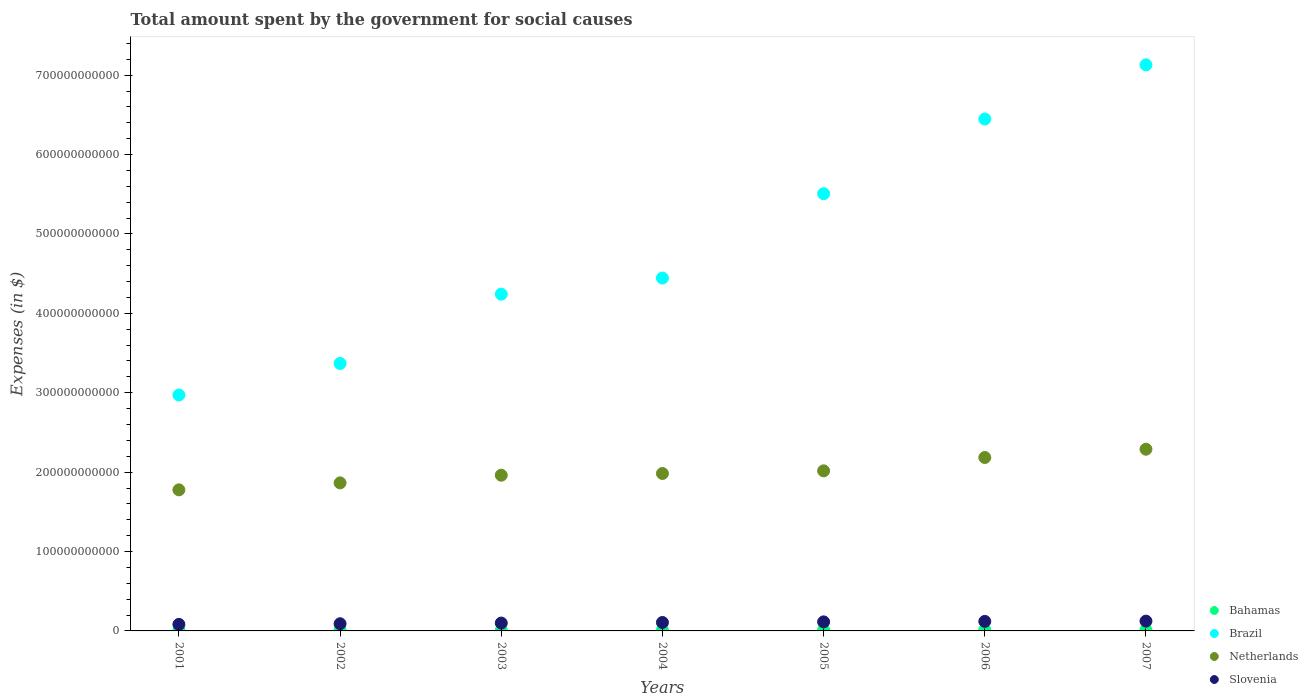How many different coloured dotlines are there?
Your answer should be compact. 4. What is the amount spent for social causes by the government in Netherlands in 2003?
Provide a succinct answer. 1.96e+11. Across all years, what is the maximum amount spent for social causes by the government in Bahamas?
Your answer should be compact. 1.26e+09. Across all years, what is the minimum amount spent for social causes by the government in Netherlands?
Provide a succinct answer. 1.78e+11. In which year was the amount spent for social causes by the government in Brazil maximum?
Ensure brevity in your answer.  2007. In which year was the amount spent for social causes by the government in Brazil minimum?
Your answer should be compact. 2001. What is the total amount spent for social causes by the government in Brazil in the graph?
Provide a short and direct response. 3.41e+12. What is the difference between the amount spent for social causes by the government in Bahamas in 2002 and that in 2003?
Keep it short and to the point. -7.63e+07. What is the difference between the amount spent for social causes by the government in Bahamas in 2004 and the amount spent for social causes by the government in Brazil in 2007?
Ensure brevity in your answer.  -7.12e+11. What is the average amount spent for social causes by the government in Netherlands per year?
Offer a terse response. 2.01e+11. In the year 2007, what is the difference between the amount spent for social causes by the government in Netherlands and amount spent for social causes by the government in Slovenia?
Make the answer very short. 2.17e+11. What is the ratio of the amount spent for social causes by the government in Brazil in 2002 to that in 2005?
Your answer should be very brief. 0.61. Is the amount spent for social causes by the government in Brazil in 2003 less than that in 2007?
Give a very brief answer. Yes. What is the difference between the highest and the second highest amount spent for social causes by the government in Netherlands?
Your response must be concise. 1.04e+1. What is the difference between the highest and the lowest amount spent for social causes by the government in Netherlands?
Ensure brevity in your answer.  5.12e+1. In how many years, is the amount spent for social causes by the government in Bahamas greater than the average amount spent for social causes by the government in Bahamas taken over all years?
Give a very brief answer. 3. Is the sum of the amount spent for social causes by the government in Slovenia in 2003 and 2005 greater than the maximum amount spent for social causes by the government in Brazil across all years?
Give a very brief answer. No. Is it the case that in every year, the sum of the amount spent for social causes by the government in Bahamas and amount spent for social causes by the government in Netherlands  is greater than the sum of amount spent for social causes by the government in Slovenia and amount spent for social causes by the government in Brazil?
Provide a succinct answer. Yes. Is the amount spent for social causes by the government in Slovenia strictly greater than the amount spent for social causes by the government in Bahamas over the years?
Make the answer very short. Yes. What is the difference between two consecutive major ticks on the Y-axis?
Your response must be concise. 1.00e+11. Are the values on the major ticks of Y-axis written in scientific E-notation?
Provide a short and direct response. No. How are the legend labels stacked?
Make the answer very short. Vertical. What is the title of the graph?
Make the answer very short. Total amount spent by the government for social causes. What is the label or title of the Y-axis?
Your answer should be compact. Expenses (in $). What is the Expenses (in $) in Bahamas in 2001?
Offer a terse response. 8.67e+08. What is the Expenses (in $) in Brazil in 2001?
Keep it short and to the point. 2.97e+11. What is the Expenses (in $) in Netherlands in 2001?
Offer a terse response. 1.78e+11. What is the Expenses (in $) of Slovenia in 2001?
Ensure brevity in your answer.  8.24e+09. What is the Expenses (in $) of Bahamas in 2002?
Provide a short and direct response. 9.23e+08. What is the Expenses (in $) of Brazil in 2002?
Provide a succinct answer. 3.37e+11. What is the Expenses (in $) in Netherlands in 2002?
Offer a terse response. 1.86e+11. What is the Expenses (in $) in Slovenia in 2002?
Provide a succinct answer. 9.05e+09. What is the Expenses (in $) in Bahamas in 2003?
Make the answer very short. 9.99e+08. What is the Expenses (in $) in Brazil in 2003?
Offer a terse response. 4.24e+11. What is the Expenses (in $) in Netherlands in 2003?
Your answer should be very brief. 1.96e+11. What is the Expenses (in $) of Slovenia in 2003?
Offer a very short reply. 9.91e+09. What is the Expenses (in $) in Bahamas in 2004?
Provide a short and direct response. 1.02e+09. What is the Expenses (in $) of Brazil in 2004?
Provide a succinct answer. 4.44e+11. What is the Expenses (in $) in Netherlands in 2004?
Make the answer very short. 1.98e+11. What is the Expenses (in $) of Slovenia in 2004?
Keep it short and to the point. 1.06e+1. What is the Expenses (in $) of Bahamas in 2005?
Your answer should be very brief. 1.12e+09. What is the Expenses (in $) of Brazil in 2005?
Your answer should be compact. 5.51e+11. What is the Expenses (in $) of Netherlands in 2005?
Offer a terse response. 2.02e+11. What is the Expenses (in $) in Slovenia in 2005?
Your response must be concise. 1.14e+1. What is the Expenses (in $) of Bahamas in 2006?
Provide a short and direct response. 1.19e+09. What is the Expenses (in $) in Brazil in 2006?
Ensure brevity in your answer.  6.45e+11. What is the Expenses (in $) of Netherlands in 2006?
Offer a very short reply. 2.18e+11. What is the Expenses (in $) of Slovenia in 2006?
Offer a very short reply. 1.20e+1. What is the Expenses (in $) of Bahamas in 2007?
Offer a very short reply. 1.26e+09. What is the Expenses (in $) of Brazil in 2007?
Offer a terse response. 7.13e+11. What is the Expenses (in $) in Netherlands in 2007?
Provide a short and direct response. 2.29e+11. What is the Expenses (in $) in Slovenia in 2007?
Provide a short and direct response. 1.23e+1. Across all years, what is the maximum Expenses (in $) of Bahamas?
Offer a very short reply. 1.26e+09. Across all years, what is the maximum Expenses (in $) in Brazil?
Your answer should be very brief. 7.13e+11. Across all years, what is the maximum Expenses (in $) in Netherlands?
Provide a short and direct response. 2.29e+11. Across all years, what is the maximum Expenses (in $) in Slovenia?
Provide a succinct answer. 1.23e+1. Across all years, what is the minimum Expenses (in $) of Bahamas?
Keep it short and to the point. 8.67e+08. Across all years, what is the minimum Expenses (in $) of Brazil?
Offer a very short reply. 2.97e+11. Across all years, what is the minimum Expenses (in $) of Netherlands?
Offer a very short reply. 1.78e+11. Across all years, what is the minimum Expenses (in $) in Slovenia?
Ensure brevity in your answer.  8.24e+09. What is the total Expenses (in $) of Bahamas in the graph?
Offer a terse response. 7.37e+09. What is the total Expenses (in $) of Brazil in the graph?
Give a very brief answer. 3.41e+12. What is the total Expenses (in $) in Netherlands in the graph?
Ensure brevity in your answer.  1.41e+12. What is the total Expenses (in $) in Slovenia in the graph?
Your answer should be compact. 7.36e+1. What is the difference between the Expenses (in $) of Bahamas in 2001 and that in 2002?
Offer a very short reply. -5.57e+07. What is the difference between the Expenses (in $) in Brazil in 2001 and that in 2002?
Your response must be concise. -3.98e+1. What is the difference between the Expenses (in $) in Netherlands in 2001 and that in 2002?
Provide a succinct answer. -8.78e+09. What is the difference between the Expenses (in $) of Slovenia in 2001 and that in 2002?
Offer a terse response. -8.08e+08. What is the difference between the Expenses (in $) in Bahamas in 2001 and that in 2003?
Your response must be concise. -1.32e+08. What is the difference between the Expenses (in $) in Brazil in 2001 and that in 2003?
Make the answer very short. -1.27e+11. What is the difference between the Expenses (in $) in Netherlands in 2001 and that in 2003?
Your answer should be compact. -1.84e+1. What is the difference between the Expenses (in $) of Slovenia in 2001 and that in 2003?
Make the answer very short. -1.67e+09. What is the difference between the Expenses (in $) of Bahamas in 2001 and that in 2004?
Your answer should be very brief. -1.54e+08. What is the difference between the Expenses (in $) of Brazil in 2001 and that in 2004?
Offer a terse response. -1.47e+11. What is the difference between the Expenses (in $) of Netherlands in 2001 and that in 2004?
Give a very brief answer. -2.06e+1. What is the difference between the Expenses (in $) of Slovenia in 2001 and that in 2004?
Your response must be concise. -2.40e+09. What is the difference between the Expenses (in $) in Bahamas in 2001 and that in 2005?
Your response must be concise. -2.50e+08. What is the difference between the Expenses (in $) of Brazil in 2001 and that in 2005?
Provide a short and direct response. -2.54e+11. What is the difference between the Expenses (in $) in Netherlands in 2001 and that in 2005?
Give a very brief answer. -2.39e+1. What is the difference between the Expenses (in $) of Slovenia in 2001 and that in 2005?
Make the answer very short. -3.15e+09. What is the difference between the Expenses (in $) of Bahamas in 2001 and that in 2006?
Keep it short and to the point. -3.19e+08. What is the difference between the Expenses (in $) of Brazil in 2001 and that in 2006?
Offer a very short reply. -3.48e+11. What is the difference between the Expenses (in $) of Netherlands in 2001 and that in 2006?
Your answer should be compact. -4.08e+1. What is the difference between the Expenses (in $) of Slovenia in 2001 and that in 2006?
Keep it short and to the point. -3.74e+09. What is the difference between the Expenses (in $) of Bahamas in 2001 and that in 2007?
Give a very brief answer. -3.93e+08. What is the difference between the Expenses (in $) in Brazil in 2001 and that in 2007?
Provide a short and direct response. -4.16e+11. What is the difference between the Expenses (in $) in Netherlands in 2001 and that in 2007?
Give a very brief answer. -5.12e+1. What is the difference between the Expenses (in $) of Slovenia in 2001 and that in 2007?
Make the answer very short. -4.08e+09. What is the difference between the Expenses (in $) in Bahamas in 2002 and that in 2003?
Offer a very short reply. -7.63e+07. What is the difference between the Expenses (in $) of Brazil in 2002 and that in 2003?
Give a very brief answer. -8.73e+1. What is the difference between the Expenses (in $) in Netherlands in 2002 and that in 2003?
Ensure brevity in your answer.  -9.66e+09. What is the difference between the Expenses (in $) of Slovenia in 2002 and that in 2003?
Offer a very short reply. -8.58e+08. What is the difference between the Expenses (in $) of Bahamas in 2002 and that in 2004?
Keep it short and to the point. -9.86e+07. What is the difference between the Expenses (in $) in Brazil in 2002 and that in 2004?
Provide a short and direct response. -1.08e+11. What is the difference between the Expenses (in $) in Netherlands in 2002 and that in 2004?
Your answer should be very brief. -1.18e+1. What is the difference between the Expenses (in $) in Slovenia in 2002 and that in 2004?
Provide a succinct answer. -1.59e+09. What is the difference between the Expenses (in $) in Bahamas in 2002 and that in 2005?
Offer a very short reply. -1.94e+08. What is the difference between the Expenses (in $) of Brazil in 2002 and that in 2005?
Your answer should be compact. -2.14e+11. What is the difference between the Expenses (in $) in Netherlands in 2002 and that in 2005?
Provide a short and direct response. -1.52e+1. What is the difference between the Expenses (in $) in Slovenia in 2002 and that in 2005?
Your answer should be very brief. -2.35e+09. What is the difference between the Expenses (in $) of Bahamas in 2002 and that in 2006?
Your response must be concise. -2.63e+08. What is the difference between the Expenses (in $) of Brazil in 2002 and that in 2006?
Ensure brevity in your answer.  -3.08e+11. What is the difference between the Expenses (in $) of Netherlands in 2002 and that in 2006?
Offer a very short reply. -3.20e+1. What is the difference between the Expenses (in $) in Slovenia in 2002 and that in 2006?
Give a very brief answer. -2.93e+09. What is the difference between the Expenses (in $) of Bahamas in 2002 and that in 2007?
Give a very brief answer. -3.37e+08. What is the difference between the Expenses (in $) in Brazil in 2002 and that in 2007?
Your response must be concise. -3.76e+11. What is the difference between the Expenses (in $) of Netherlands in 2002 and that in 2007?
Make the answer very short. -4.24e+1. What is the difference between the Expenses (in $) of Slovenia in 2002 and that in 2007?
Offer a very short reply. -3.27e+09. What is the difference between the Expenses (in $) in Bahamas in 2003 and that in 2004?
Your answer should be very brief. -2.23e+07. What is the difference between the Expenses (in $) of Brazil in 2003 and that in 2004?
Your response must be concise. -2.03e+1. What is the difference between the Expenses (in $) in Netherlands in 2003 and that in 2004?
Offer a terse response. -2.17e+09. What is the difference between the Expenses (in $) of Slovenia in 2003 and that in 2004?
Your response must be concise. -7.35e+08. What is the difference between the Expenses (in $) in Bahamas in 2003 and that in 2005?
Keep it short and to the point. -1.18e+08. What is the difference between the Expenses (in $) of Brazil in 2003 and that in 2005?
Offer a terse response. -1.27e+11. What is the difference between the Expenses (in $) in Netherlands in 2003 and that in 2005?
Your answer should be compact. -5.50e+09. What is the difference between the Expenses (in $) of Slovenia in 2003 and that in 2005?
Provide a short and direct response. -1.49e+09. What is the difference between the Expenses (in $) in Bahamas in 2003 and that in 2006?
Offer a terse response. -1.87e+08. What is the difference between the Expenses (in $) of Brazil in 2003 and that in 2006?
Offer a very short reply. -2.21e+11. What is the difference between the Expenses (in $) in Netherlands in 2003 and that in 2006?
Your response must be concise. -2.23e+1. What is the difference between the Expenses (in $) of Slovenia in 2003 and that in 2006?
Your response must be concise. -2.07e+09. What is the difference between the Expenses (in $) in Bahamas in 2003 and that in 2007?
Make the answer very short. -2.61e+08. What is the difference between the Expenses (in $) in Brazil in 2003 and that in 2007?
Offer a terse response. -2.89e+11. What is the difference between the Expenses (in $) in Netherlands in 2003 and that in 2007?
Your answer should be very brief. -3.27e+1. What is the difference between the Expenses (in $) of Slovenia in 2003 and that in 2007?
Make the answer very short. -2.42e+09. What is the difference between the Expenses (in $) of Bahamas in 2004 and that in 2005?
Make the answer very short. -9.59e+07. What is the difference between the Expenses (in $) in Brazil in 2004 and that in 2005?
Keep it short and to the point. -1.06e+11. What is the difference between the Expenses (in $) in Netherlands in 2004 and that in 2005?
Ensure brevity in your answer.  -3.33e+09. What is the difference between the Expenses (in $) in Slovenia in 2004 and that in 2005?
Offer a very short reply. -7.52e+08. What is the difference between the Expenses (in $) of Bahamas in 2004 and that in 2006?
Provide a succinct answer. -1.65e+08. What is the difference between the Expenses (in $) of Brazil in 2004 and that in 2006?
Provide a short and direct response. -2.00e+11. What is the difference between the Expenses (in $) in Netherlands in 2004 and that in 2006?
Keep it short and to the point. -2.01e+1. What is the difference between the Expenses (in $) in Slovenia in 2004 and that in 2006?
Make the answer very short. -1.34e+09. What is the difference between the Expenses (in $) in Bahamas in 2004 and that in 2007?
Offer a very short reply. -2.39e+08. What is the difference between the Expenses (in $) of Brazil in 2004 and that in 2007?
Ensure brevity in your answer.  -2.69e+11. What is the difference between the Expenses (in $) of Netherlands in 2004 and that in 2007?
Make the answer very short. -3.06e+1. What is the difference between the Expenses (in $) in Slovenia in 2004 and that in 2007?
Your answer should be compact. -1.68e+09. What is the difference between the Expenses (in $) of Bahamas in 2005 and that in 2006?
Ensure brevity in your answer.  -6.87e+07. What is the difference between the Expenses (in $) of Brazil in 2005 and that in 2006?
Your answer should be very brief. -9.40e+1. What is the difference between the Expenses (in $) in Netherlands in 2005 and that in 2006?
Offer a terse response. -1.68e+1. What is the difference between the Expenses (in $) in Slovenia in 2005 and that in 2006?
Make the answer very short. -5.86e+08. What is the difference between the Expenses (in $) of Bahamas in 2005 and that in 2007?
Provide a short and direct response. -1.43e+08. What is the difference between the Expenses (in $) of Brazil in 2005 and that in 2007?
Your answer should be very brief. -1.62e+11. What is the difference between the Expenses (in $) of Netherlands in 2005 and that in 2007?
Your response must be concise. -2.72e+1. What is the difference between the Expenses (in $) in Slovenia in 2005 and that in 2007?
Offer a terse response. -9.30e+08. What is the difference between the Expenses (in $) in Bahamas in 2006 and that in 2007?
Your response must be concise. -7.43e+07. What is the difference between the Expenses (in $) in Brazil in 2006 and that in 2007?
Offer a terse response. -6.83e+1. What is the difference between the Expenses (in $) in Netherlands in 2006 and that in 2007?
Your answer should be compact. -1.04e+1. What is the difference between the Expenses (in $) in Slovenia in 2006 and that in 2007?
Ensure brevity in your answer.  -3.44e+08. What is the difference between the Expenses (in $) in Bahamas in 2001 and the Expenses (in $) in Brazil in 2002?
Offer a terse response. -3.36e+11. What is the difference between the Expenses (in $) in Bahamas in 2001 and the Expenses (in $) in Netherlands in 2002?
Your answer should be compact. -1.86e+11. What is the difference between the Expenses (in $) in Bahamas in 2001 and the Expenses (in $) in Slovenia in 2002?
Your response must be concise. -8.18e+09. What is the difference between the Expenses (in $) of Brazil in 2001 and the Expenses (in $) of Netherlands in 2002?
Your response must be concise. 1.11e+11. What is the difference between the Expenses (in $) of Brazil in 2001 and the Expenses (in $) of Slovenia in 2002?
Offer a very short reply. 2.88e+11. What is the difference between the Expenses (in $) of Netherlands in 2001 and the Expenses (in $) of Slovenia in 2002?
Your answer should be compact. 1.69e+11. What is the difference between the Expenses (in $) of Bahamas in 2001 and the Expenses (in $) of Brazil in 2003?
Keep it short and to the point. -4.23e+11. What is the difference between the Expenses (in $) of Bahamas in 2001 and the Expenses (in $) of Netherlands in 2003?
Provide a succinct answer. -1.95e+11. What is the difference between the Expenses (in $) in Bahamas in 2001 and the Expenses (in $) in Slovenia in 2003?
Ensure brevity in your answer.  -9.04e+09. What is the difference between the Expenses (in $) of Brazil in 2001 and the Expenses (in $) of Netherlands in 2003?
Provide a short and direct response. 1.01e+11. What is the difference between the Expenses (in $) in Brazil in 2001 and the Expenses (in $) in Slovenia in 2003?
Offer a terse response. 2.87e+11. What is the difference between the Expenses (in $) of Netherlands in 2001 and the Expenses (in $) of Slovenia in 2003?
Your answer should be very brief. 1.68e+11. What is the difference between the Expenses (in $) of Bahamas in 2001 and the Expenses (in $) of Brazil in 2004?
Your response must be concise. -4.44e+11. What is the difference between the Expenses (in $) of Bahamas in 2001 and the Expenses (in $) of Netherlands in 2004?
Provide a short and direct response. -1.97e+11. What is the difference between the Expenses (in $) of Bahamas in 2001 and the Expenses (in $) of Slovenia in 2004?
Provide a succinct answer. -9.78e+09. What is the difference between the Expenses (in $) in Brazil in 2001 and the Expenses (in $) in Netherlands in 2004?
Provide a succinct answer. 9.88e+1. What is the difference between the Expenses (in $) of Brazil in 2001 and the Expenses (in $) of Slovenia in 2004?
Ensure brevity in your answer.  2.86e+11. What is the difference between the Expenses (in $) in Netherlands in 2001 and the Expenses (in $) in Slovenia in 2004?
Your answer should be very brief. 1.67e+11. What is the difference between the Expenses (in $) in Bahamas in 2001 and the Expenses (in $) in Brazil in 2005?
Give a very brief answer. -5.50e+11. What is the difference between the Expenses (in $) of Bahamas in 2001 and the Expenses (in $) of Netherlands in 2005?
Provide a succinct answer. -2.01e+11. What is the difference between the Expenses (in $) of Bahamas in 2001 and the Expenses (in $) of Slovenia in 2005?
Offer a very short reply. -1.05e+1. What is the difference between the Expenses (in $) in Brazil in 2001 and the Expenses (in $) in Netherlands in 2005?
Ensure brevity in your answer.  9.55e+1. What is the difference between the Expenses (in $) in Brazil in 2001 and the Expenses (in $) in Slovenia in 2005?
Offer a terse response. 2.86e+11. What is the difference between the Expenses (in $) of Netherlands in 2001 and the Expenses (in $) of Slovenia in 2005?
Your answer should be compact. 1.66e+11. What is the difference between the Expenses (in $) in Bahamas in 2001 and the Expenses (in $) in Brazil in 2006?
Offer a very short reply. -6.44e+11. What is the difference between the Expenses (in $) of Bahamas in 2001 and the Expenses (in $) of Netherlands in 2006?
Offer a very short reply. -2.18e+11. What is the difference between the Expenses (in $) of Bahamas in 2001 and the Expenses (in $) of Slovenia in 2006?
Make the answer very short. -1.11e+1. What is the difference between the Expenses (in $) in Brazil in 2001 and the Expenses (in $) in Netherlands in 2006?
Provide a succinct answer. 7.87e+1. What is the difference between the Expenses (in $) of Brazil in 2001 and the Expenses (in $) of Slovenia in 2006?
Give a very brief answer. 2.85e+11. What is the difference between the Expenses (in $) of Netherlands in 2001 and the Expenses (in $) of Slovenia in 2006?
Keep it short and to the point. 1.66e+11. What is the difference between the Expenses (in $) in Bahamas in 2001 and the Expenses (in $) in Brazil in 2007?
Offer a terse response. -7.12e+11. What is the difference between the Expenses (in $) in Bahamas in 2001 and the Expenses (in $) in Netherlands in 2007?
Give a very brief answer. -2.28e+11. What is the difference between the Expenses (in $) of Bahamas in 2001 and the Expenses (in $) of Slovenia in 2007?
Your answer should be compact. -1.15e+1. What is the difference between the Expenses (in $) in Brazil in 2001 and the Expenses (in $) in Netherlands in 2007?
Your answer should be compact. 6.83e+1. What is the difference between the Expenses (in $) of Brazil in 2001 and the Expenses (in $) of Slovenia in 2007?
Offer a terse response. 2.85e+11. What is the difference between the Expenses (in $) of Netherlands in 2001 and the Expenses (in $) of Slovenia in 2007?
Provide a short and direct response. 1.65e+11. What is the difference between the Expenses (in $) of Bahamas in 2002 and the Expenses (in $) of Brazil in 2003?
Provide a succinct answer. -4.23e+11. What is the difference between the Expenses (in $) of Bahamas in 2002 and the Expenses (in $) of Netherlands in 2003?
Give a very brief answer. -1.95e+11. What is the difference between the Expenses (in $) of Bahamas in 2002 and the Expenses (in $) of Slovenia in 2003?
Make the answer very short. -8.99e+09. What is the difference between the Expenses (in $) of Brazil in 2002 and the Expenses (in $) of Netherlands in 2003?
Your answer should be very brief. 1.41e+11. What is the difference between the Expenses (in $) in Brazil in 2002 and the Expenses (in $) in Slovenia in 2003?
Your answer should be very brief. 3.27e+11. What is the difference between the Expenses (in $) of Netherlands in 2002 and the Expenses (in $) of Slovenia in 2003?
Ensure brevity in your answer.  1.77e+11. What is the difference between the Expenses (in $) in Bahamas in 2002 and the Expenses (in $) in Brazil in 2004?
Offer a terse response. -4.43e+11. What is the difference between the Expenses (in $) in Bahamas in 2002 and the Expenses (in $) in Netherlands in 2004?
Your answer should be compact. -1.97e+11. What is the difference between the Expenses (in $) of Bahamas in 2002 and the Expenses (in $) of Slovenia in 2004?
Your answer should be very brief. -9.72e+09. What is the difference between the Expenses (in $) of Brazil in 2002 and the Expenses (in $) of Netherlands in 2004?
Ensure brevity in your answer.  1.39e+11. What is the difference between the Expenses (in $) in Brazil in 2002 and the Expenses (in $) in Slovenia in 2004?
Ensure brevity in your answer.  3.26e+11. What is the difference between the Expenses (in $) in Netherlands in 2002 and the Expenses (in $) in Slovenia in 2004?
Give a very brief answer. 1.76e+11. What is the difference between the Expenses (in $) in Bahamas in 2002 and the Expenses (in $) in Brazil in 2005?
Ensure brevity in your answer.  -5.50e+11. What is the difference between the Expenses (in $) of Bahamas in 2002 and the Expenses (in $) of Netherlands in 2005?
Provide a short and direct response. -2.01e+11. What is the difference between the Expenses (in $) of Bahamas in 2002 and the Expenses (in $) of Slovenia in 2005?
Ensure brevity in your answer.  -1.05e+1. What is the difference between the Expenses (in $) of Brazil in 2002 and the Expenses (in $) of Netherlands in 2005?
Offer a terse response. 1.35e+11. What is the difference between the Expenses (in $) in Brazil in 2002 and the Expenses (in $) in Slovenia in 2005?
Your answer should be very brief. 3.25e+11. What is the difference between the Expenses (in $) in Netherlands in 2002 and the Expenses (in $) in Slovenia in 2005?
Provide a succinct answer. 1.75e+11. What is the difference between the Expenses (in $) in Bahamas in 2002 and the Expenses (in $) in Brazil in 2006?
Offer a terse response. -6.44e+11. What is the difference between the Expenses (in $) in Bahamas in 2002 and the Expenses (in $) in Netherlands in 2006?
Offer a very short reply. -2.18e+11. What is the difference between the Expenses (in $) in Bahamas in 2002 and the Expenses (in $) in Slovenia in 2006?
Your answer should be very brief. -1.11e+1. What is the difference between the Expenses (in $) of Brazil in 2002 and the Expenses (in $) of Netherlands in 2006?
Your answer should be compact. 1.18e+11. What is the difference between the Expenses (in $) of Brazil in 2002 and the Expenses (in $) of Slovenia in 2006?
Your answer should be very brief. 3.25e+11. What is the difference between the Expenses (in $) in Netherlands in 2002 and the Expenses (in $) in Slovenia in 2006?
Offer a terse response. 1.74e+11. What is the difference between the Expenses (in $) in Bahamas in 2002 and the Expenses (in $) in Brazil in 2007?
Offer a very short reply. -7.12e+11. What is the difference between the Expenses (in $) of Bahamas in 2002 and the Expenses (in $) of Netherlands in 2007?
Your answer should be compact. -2.28e+11. What is the difference between the Expenses (in $) in Bahamas in 2002 and the Expenses (in $) in Slovenia in 2007?
Keep it short and to the point. -1.14e+1. What is the difference between the Expenses (in $) of Brazil in 2002 and the Expenses (in $) of Netherlands in 2007?
Your answer should be compact. 1.08e+11. What is the difference between the Expenses (in $) of Brazil in 2002 and the Expenses (in $) of Slovenia in 2007?
Make the answer very short. 3.25e+11. What is the difference between the Expenses (in $) of Netherlands in 2002 and the Expenses (in $) of Slovenia in 2007?
Offer a terse response. 1.74e+11. What is the difference between the Expenses (in $) in Bahamas in 2003 and the Expenses (in $) in Brazil in 2004?
Your response must be concise. -4.43e+11. What is the difference between the Expenses (in $) in Bahamas in 2003 and the Expenses (in $) in Netherlands in 2004?
Provide a succinct answer. -1.97e+11. What is the difference between the Expenses (in $) of Bahamas in 2003 and the Expenses (in $) of Slovenia in 2004?
Offer a very short reply. -9.65e+09. What is the difference between the Expenses (in $) of Brazil in 2003 and the Expenses (in $) of Netherlands in 2004?
Offer a very short reply. 2.26e+11. What is the difference between the Expenses (in $) of Brazil in 2003 and the Expenses (in $) of Slovenia in 2004?
Provide a short and direct response. 4.13e+11. What is the difference between the Expenses (in $) in Netherlands in 2003 and the Expenses (in $) in Slovenia in 2004?
Keep it short and to the point. 1.85e+11. What is the difference between the Expenses (in $) of Bahamas in 2003 and the Expenses (in $) of Brazil in 2005?
Provide a succinct answer. -5.50e+11. What is the difference between the Expenses (in $) of Bahamas in 2003 and the Expenses (in $) of Netherlands in 2005?
Ensure brevity in your answer.  -2.01e+11. What is the difference between the Expenses (in $) in Bahamas in 2003 and the Expenses (in $) in Slovenia in 2005?
Ensure brevity in your answer.  -1.04e+1. What is the difference between the Expenses (in $) of Brazil in 2003 and the Expenses (in $) of Netherlands in 2005?
Your answer should be compact. 2.23e+11. What is the difference between the Expenses (in $) in Brazil in 2003 and the Expenses (in $) in Slovenia in 2005?
Your answer should be very brief. 4.13e+11. What is the difference between the Expenses (in $) in Netherlands in 2003 and the Expenses (in $) in Slovenia in 2005?
Keep it short and to the point. 1.85e+11. What is the difference between the Expenses (in $) of Bahamas in 2003 and the Expenses (in $) of Brazil in 2006?
Your answer should be compact. -6.44e+11. What is the difference between the Expenses (in $) in Bahamas in 2003 and the Expenses (in $) in Netherlands in 2006?
Give a very brief answer. -2.17e+11. What is the difference between the Expenses (in $) of Bahamas in 2003 and the Expenses (in $) of Slovenia in 2006?
Your answer should be very brief. -1.10e+1. What is the difference between the Expenses (in $) in Brazil in 2003 and the Expenses (in $) in Netherlands in 2006?
Give a very brief answer. 2.06e+11. What is the difference between the Expenses (in $) of Brazil in 2003 and the Expenses (in $) of Slovenia in 2006?
Ensure brevity in your answer.  4.12e+11. What is the difference between the Expenses (in $) in Netherlands in 2003 and the Expenses (in $) in Slovenia in 2006?
Provide a succinct answer. 1.84e+11. What is the difference between the Expenses (in $) of Bahamas in 2003 and the Expenses (in $) of Brazil in 2007?
Your answer should be compact. -7.12e+11. What is the difference between the Expenses (in $) in Bahamas in 2003 and the Expenses (in $) in Netherlands in 2007?
Offer a very short reply. -2.28e+11. What is the difference between the Expenses (in $) in Bahamas in 2003 and the Expenses (in $) in Slovenia in 2007?
Make the answer very short. -1.13e+1. What is the difference between the Expenses (in $) of Brazil in 2003 and the Expenses (in $) of Netherlands in 2007?
Your response must be concise. 1.95e+11. What is the difference between the Expenses (in $) of Brazil in 2003 and the Expenses (in $) of Slovenia in 2007?
Your answer should be compact. 4.12e+11. What is the difference between the Expenses (in $) in Netherlands in 2003 and the Expenses (in $) in Slovenia in 2007?
Give a very brief answer. 1.84e+11. What is the difference between the Expenses (in $) in Bahamas in 2004 and the Expenses (in $) in Brazil in 2005?
Offer a very short reply. -5.50e+11. What is the difference between the Expenses (in $) in Bahamas in 2004 and the Expenses (in $) in Netherlands in 2005?
Keep it short and to the point. -2.01e+11. What is the difference between the Expenses (in $) in Bahamas in 2004 and the Expenses (in $) in Slovenia in 2005?
Your answer should be compact. -1.04e+1. What is the difference between the Expenses (in $) in Brazil in 2004 and the Expenses (in $) in Netherlands in 2005?
Your answer should be very brief. 2.43e+11. What is the difference between the Expenses (in $) in Brazil in 2004 and the Expenses (in $) in Slovenia in 2005?
Your answer should be compact. 4.33e+11. What is the difference between the Expenses (in $) of Netherlands in 2004 and the Expenses (in $) of Slovenia in 2005?
Keep it short and to the point. 1.87e+11. What is the difference between the Expenses (in $) of Bahamas in 2004 and the Expenses (in $) of Brazil in 2006?
Give a very brief answer. -6.44e+11. What is the difference between the Expenses (in $) of Bahamas in 2004 and the Expenses (in $) of Netherlands in 2006?
Your answer should be very brief. -2.17e+11. What is the difference between the Expenses (in $) of Bahamas in 2004 and the Expenses (in $) of Slovenia in 2006?
Ensure brevity in your answer.  -1.10e+1. What is the difference between the Expenses (in $) of Brazil in 2004 and the Expenses (in $) of Netherlands in 2006?
Your answer should be compact. 2.26e+11. What is the difference between the Expenses (in $) of Brazil in 2004 and the Expenses (in $) of Slovenia in 2006?
Give a very brief answer. 4.32e+11. What is the difference between the Expenses (in $) in Netherlands in 2004 and the Expenses (in $) in Slovenia in 2006?
Keep it short and to the point. 1.86e+11. What is the difference between the Expenses (in $) of Bahamas in 2004 and the Expenses (in $) of Brazil in 2007?
Provide a short and direct response. -7.12e+11. What is the difference between the Expenses (in $) in Bahamas in 2004 and the Expenses (in $) in Netherlands in 2007?
Provide a short and direct response. -2.28e+11. What is the difference between the Expenses (in $) in Bahamas in 2004 and the Expenses (in $) in Slovenia in 2007?
Your answer should be compact. -1.13e+1. What is the difference between the Expenses (in $) in Brazil in 2004 and the Expenses (in $) in Netherlands in 2007?
Your response must be concise. 2.16e+11. What is the difference between the Expenses (in $) in Brazil in 2004 and the Expenses (in $) in Slovenia in 2007?
Keep it short and to the point. 4.32e+11. What is the difference between the Expenses (in $) of Netherlands in 2004 and the Expenses (in $) of Slovenia in 2007?
Your answer should be compact. 1.86e+11. What is the difference between the Expenses (in $) in Bahamas in 2005 and the Expenses (in $) in Brazil in 2006?
Offer a terse response. -6.44e+11. What is the difference between the Expenses (in $) in Bahamas in 2005 and the Expenses (in $) in Netherlands in 2006?
Provide a short and direct response. -2.17e+11. What is the difference between the Expenses (in $) of Bahamas in 2005 and the Expenses (in $) of Slovenia in 2006?
Your response must be concise. -1.09e+1. What is the difference between the Expenses (in $) in Brazil in 2005 and the Expenses (in $) in Netherlands in 2006?
Your response must be concise. 3.32e+11. What is the difference between the Expenses (in $) of Brazil in 2005 and the Expenses (in $) of Slovenia in 2006?
Make the answer very short. 5.39e+11. What is the difference between the Expenses (in $) of Netherlands in 2005 and the Expenses (in $) of Slovenia in 2006?
Provide a succinct answer. 1.90e+11. What is the difference between the Expenses (in $) of Bahamas in 2005 and the Expenses (in $) of Brazil in 2007?
Provide a short and direct response. -7.12e+11. What is the difference between the Expenses (in $) in Bahamas in 2005 and the Expenses (in $) in Netherlands in 2007?
Your response must be concise. -2.28e+11. What is the difference between the Expenses (in $) in Bahamas in 2005 and the Expenses (in $) in Slovenia in 2007?
Give a very brief answer. -1.12e+1. What is the difference between the Expenses (in $) in Brazil in 2005 and the Expenses (in $) in Netherlands in 2007?
Keep it short and to the point. 3.22e+11. What is the difference between the Expenses (in $) in Brazil in 2005 and the Expenses (in $) in Slovenia in 2007?
Give a very brief answer. 5.38e+11. What is the difference between the Expenses (in $) in Netherlands in 2005 and the Expenses (in $) in Slovenia in 2007?
Ensure brevity in your answer.  1.89e+11. What is the difference between the Expenses (in $) in Bahamas in 2006 and the Expenses (in $) in Brazil in 2007?
Your answer should be compact. -7.12e+11. What is the difference between the Expenses (in $) in Bahamas in 2006 and the Expenses (in $) in Netherlands in 2007?
Keep it short and to the point. -2.28e+11. What is the difference between the Expenses (in $) of Bahamas in 2006 and the Expenses (in $) of Slovenia in 2007?
Make the answer very short. -1.11e+1. What is the difference between the Expenses (in $) in Brazil in 2006 and the Expenses (in $) in Netherlands in 2007?
Give a very brief answer. 4.16e+11. What is the difference between the Expenses (in $) in Brazil in 2006 and the Expenses (in $) in Slovenia in 2007?
Your response must be concise. 6.32e+11. What is the difference between the Expenses (in $) of Netherlands in 2006 and the Expenses (in $) of Slovenia in 2007?
Offer a very short reply. 2.06e+11. What is the average Expenses (in $) of Bahamas per year?
Give a very brief answer. 1.05e+09. What is the average Expenses (in $) of Brazil per year?
Your answer should be very brief. 4.87e+11. What is the average Expenses (in $) in Netherlands per year?
Provide a succinct answer. 2.01e+11. What is the average Expenses (in $) in Slovenia per year?
Offer a terse response. 1.05e+1. In the year 2001, what is the difference between the Expenses (in $) of Bahamas and Expenses (in $) of Brazil?
Offer a terse response. -2.96e+11. In the year 2001, what is the difference between the Expenses (in $) in Bahamas and Expenses (in $) in Netherlands?
Offer a terse response. -1.77e+11. In the year 2001, what is the difference between the Expenses (in $) of Bahamas and Expenses (in $) of Slovenia?
Provide a short and direct response. -7.38e+09. In the year 2001, what is the difference between the Expenses (in $) in Brazil and Expenses (in $) in Netherlands?
Offer a terse response. 1.19e+11. In the year 2001, what is the difference between the Expenses (in $) in Brazil and Expenses (in $) in Slovenia?
Offer a terse response. 2.89e+11. In the year 2001, what is the difference between the Expenses (in $) in Netherlands and Expenses (in $) in Slovenia?
Provide a succinct answer. 1.69e+11. In the year 2002, what is the difference between the Expenses (in $) of Bahamas and Expenses (in $) of Brazil?
Offer a very short reply. -3.36e+11. In the year 2002, what is the difference between the Expenses (in $) in Bahamas and Expenses (in $) in Netherlands?
Make the answer very short. -1.86e+11. In the year 2002, what is the difference between the Expenses (in $) of Bahamas and Expenses (in $) of Slovenia?
Offer a terse response. -8.13e+09. In the year 2002, what is the difference between the Expenses (in $) in Brazil and Expenses (in $) in Netherlands?
Give a very brief answer. 1.50e+11. In the year 2002, what is the difference between the Expenses (in $) in Brazil and Expenses (in $) in Slovenia?
Make the answer very short. 3.28e+11. In the year 2002, what is the difference between the Expenses (in $) in Netherlands and Expenses (in $) in Slovenia?
Provide a short and direct response. 1.77e+11. In the year 2003, what is the difference between the Expenses (in $) of Bahamas and Expenses (in $) of Brazil?
Give a very brief answer. -4.23e+11. In the year 2003, what is the difference between the Expenses (in $) in Bahamas and Expenses (in $) in Netherlands?
Your response must be concise. -1.95e+11. In the year 2003, what is the difference between the Expenses (in $) in Bahamas and Expenses (in $) in Slovenia?
Ensure brevity in your answer.  -8.91e+09. In the year 2003, what is the difference between the Expenses (in $) of Brazil and Expenses (in $) of Netherlands?
Offer a very short reply. 2.28e+11. In the year 2003, what is the difference between the Expenses (in $) in Brazil and Expenses (in $) in Slovenia?
Your answer should be very brief. 4.14e+11. In the year 2003, what is the difference between the Expenses (in $) of Netherlands and Expenses (in $) of Slovenia?
Give a very brief answer. 1.86e+11. In the year 2004, what is the difference between the Expenses (in $) in Bahamas and Expenses (in $) in Brazil?
Provide a succinct answer. -4.43e+11. In the year 2004, what is the difference between the Expenses (in $) of Bahamas and Expenses (in $) of Netherlands?
Give a very brief answer. -1.97e+11. In the year 2004, what is the difference between the Expenses (in $) of Bahamas and Expenses (in $) of Slovenia?
Provide a succinct answer. -9.62e+09. In the year 2004, what is the difference between the Expenses (in $) of Brazil and Expenses (in $) of Netherlands?
Provide a short and direct response. 2.46e+11. In the year 2004, what is the difference between the Expenses (in $) of Brazil and Expenses (in $) of Slovenia?
Provide a short and direct response. 4.34e+11. In the year 2004, what is the difference between the Expenses (in $) of Netherlands and Expenses (in $) of Slovenia?
Keep it short and to the point. 1.88e+11. In the year 2005, what is the difference between the Expenses (in $) of Bahamas and Expenses (in $) of Brazil?
Keep it short and to the point. -5.50e+11. In the year 2005, what is the difference between the Expenses (in $) of Bahamas and Expenses (in $) of Netherlands?
Offer a very short reply. -2.00e+11. In the year 2005, what is the difference between the Expenses (in $) of Bahamas and Expenses (in $) of Slovenia?
Provide a short and direct response. -1.03e+1. In the year 2005, what is the difference between the Expenses (in $) in Brazil and Expenses (in $) in Netherlands?
Your response must be concise. 3.49e+11. In the year 2005, what is the difference between the Expenses (in $) in Brazil and Expenses (in $) in Slovenia?
Give a very brief answer. 5.39e+11. In the year 2005, what is the difference between the Expenses (in $) in Netherlands and Expenses (in $) in Slovenia?
Make the answer very short. 1.90e+11. In the year 2006, what is the difference between the Expenses (in $) in Bahamas and Expenses (in $) in Brazil?
Give a very brief answer. -6.43e+11. In the year 2006, what is the difference between the Expenses (in $) of Bahamas and Expenses (in $) of Netherlands?
Keep it short and to the point. -2.17e+11. In the year 2006, what is the difference between the Expenses (in $) in Bahamas and Expenses (in $) in Slovenia?
Keep it short and to the point. -1.08e+1. In the year 2006, what is the difference between the Expenses (in $) in Brazil and Expenses (in $) in Netherlands?
Your answer should be compact. 4.26e+11. In the year 2006, what is the difference between the Expenses (in $) of Brazil and Expenses (in $) of Slovenia?
Offer a terse response. 6.33e+11. In the year 2006, what is the difference between the Expenses (in $) in Netherlands and Expenses (in $) in Slovenia?
Offer a very short reply. 2.06e+11. In the year 2007, what is the difference between the Expenses (in $) of Bahamas and Expenses (in $) of Brazil?
Your response must be concise. -7.12e+11. In the year 2007, what is the difference between the Expenses (in $) of Bahamas and Expenses (in $) of Netherlands?
Keep it short and to the point. -2.28e+11. In the year 2007, what is the difference between the Expenses (in $) in Bahamas and Expenses (in $) in Slovenia?
Make the answer very short. -1.11e+1. In the year 2007, what is the difference between the Expenses (in $) of Brazil and Expenses (in $) of Netherlands?
Your answer should be compact. 4.84e+11. In the year 2007, what is the difference between the Expenses (in $) in Brazil and Expenses (in $) in Slovenia?
Make the answer very short. 7.01e+11. In the year 2007, what is the difference between the Expenses (in $) of Netherlands and Expenses (in $) of Slovenia?
Ensure brevity in your answer.  2.17e+11. What is the ratio of the Expenses (in $) in Bahamas in 2001 to that in 2002?
Give a very brief answer. 0.94. What is the ratio of the Expenses (in $) of Brazil in 2001 to that in 2002?
Your response must be concise. 0.88. What is the ratio of the Expenses (in $) of Netherlands in 2001 to that in 2002?
Your answer should be compact. 0.95. What is the ratio of the Expenses (in $) in Slovenia in 2001 to that in 2002?
Provide a succinct answer. 0.91. What is the ratio of the Expenses (in $) in Bahamas in 2001 to that in 2003?
Make the answer very short. 0.87. What is the ratio of the Expenses (in $) in Brazil in 2001 to that in 2003?
Offer a very short reply. 0.7. What is the ratio of the Expenses (in $) in Netherlands in 2001 to that in 2003?
Offer a very short reply. 0.91. What is the ratio of the Expenses (in $) of Slovenia in 2001 to that in 2003?
Provide a succinct answer. 0.83. What is the ratio of the Expenses (in $) in Bahamas in 2001 to that in 2004?
Ensure brevity in your answer.  0.85. What is the ratio of the Expenses (in $) in Brazil in 2001 to that in 2004?
Your response must be concise. 0.67. What is the ratio of the Expenses (in $) in Netherlands in 2001 to that in 2004?
Your response must be concise. 0.9. What is the ratio of the Expenses (in $) of Slovenia in 2001 to that in 2004?
Your answer should be very brief. 0.77. What is the ratio of the Expenses (in $) in Bahamas in 2001 to that in 2005?
Offer a very short reply. 0.78. What is the ratio of the Expenses (in $) of Brazil in 2001 to that in 2005?
Keep it short and to the point. 0.54. What is the ratio of the Expenses (in $) in Netherlands in 2001 to that in 2005?
Your response must be concise. 0.88. What is the ratio of the Expenses (in $) in Slovenia in 2001 to that in 2005?
Give a very brief answer. 0.72. What is the ratio of the Expenses (in $) of Bahamas in 2001 to that in 2006?
Your response must be concise. 0.73. What is the ratio of the Expenses (in $) of Brazil in 2001 to that in 2006?
Ensure brevity in your answer.  0.46. What is the ratio of the Expenses (in $) of Netherlands in 2001 to that in 2006?
Your response must be concise. 0.81. What is the ratio of the Expenses (in $) of Slovenia in 2001 to that in 2006?
Offer a terse response. 0.69. What is the ratio of the Expenses (in $) of Bahamas in 2001 to that in 2007?
Ensure brevity in your answer.  0.69. What is the ratio of the Expenses (in $) in Brazil in 2001 to that in 2007?
Your answer should be very brief. 0.42. What is the ratio of the Expenses (in $) in Netherlands in 2001 to that in 2007?
Offer a terse response. 0.78. What is the ratio of the Expenses (in $) of Slovenia in 2001 to that in 2007?
Provide a short and direct response. 0.67. What is the ratio of the Expenses (in $) in Bahamas in 2002 to that in 2003?
Your answer should be compact. 0.92. What is the ratio of the Expenses (in $) in Brazil in 2002 to that in 2003?
Offer a very short reply. 0.79. What is the ratio of the Expenses (in $) in Netherlands in 2002 to that in 2003?
Your answer should be very brief. 0.95. What is the ratio of the Expenses (in $) in Slovenia in 2002 to that in 2003?
Ensure brevity in your answer.  0.91. What is the ratio of the Expenses (in $) of Bahamas in 2002 to that in 2004?
Provide a succinct answer. 0.9. What is the ratio of the Expenses (in $) in Brazil in 2002 to that in 2004?
Your response must be concise. 0.76. What is the ratio of the Expenses (in $) of Netherlands in 2002 to that in 2004?
Ensure brevity in your answer.  0.94. What is the ratio of the Expenses (in $) in Slovenia in 2002 to that in 2004?
Offer a very short reply. 0.85. What is the ratio of the Expenses (in $) in Bahamas in 2002 to that in 2005?
Provide a succinct answer. 0.83. What is the ratio of the Expenses (in $) of Brazil in 2002 to that in 2005?
Offer a very short reply. 0.61. What is the ratio of the Expenses (in $) of Netherlands in 2002 to that in 2005?
Provide a short and direct response. 0.92. What is the ratio of the Expenses (in $) in Slovenia in 2002 to that in 2005?
Offer a terse response. 0.79. What is the ratio of the Expenses (in $) in Bahamas in 2002 to that in 2006?
Your answer should be compact. 0.78. What is the ratio of the Expenses (in $) of Brazil in 2002 to that in 2006?
Offer a very short reply. 0.52. What is the ratio of the Expenses (in $) in Netherlands in 2002 to that in 2006?
Your answer should be compact. 0.85. What is the ratio of the Expenses (in $) of Slovenia in 2002 to that in 2006?
Offer a terse response. 0.76. What is the ratio of the Expenses (in $) in Bahamas in 2002 to that in 2007?
Provide a succinct answer. 0.73. What is the ratio of the Expenses (in $) in Brazil in 2002 to that in 2007?
Your answer should be very brief. 0.47. What is the ratio of the Expenses (in $) in Netherlands in 2002 to that in 2007?
Offer a very short reply. 0.81. What is the ratio of the Expenses (in $) of Slovenia in 2002 to that in 2007?
Offer a very short reply. 0.73. What is the ratio of the Expenses (in $) in Bahamas in 2003 to that in 2004?
Offer a terse response. 0.98. What is the ratio of the Expenses (in $) of Brazil in 2003 to that in 2004?
Give a very brief answer. 0.95. What is the ratio of the Expenses (in $) in Slovenia in 2003 to that in 2004?
Give a very brief answer. 0.93. What is the ratio of the Expenses (in $) of Bahamas in 2003 to that in 2005?
Your response must be concise. 0.89. What is the ratio of the Expenses (in $) of Brazil in 2003 to that in 2005?
Your answer should be very brief. 0.77. What is the ratio of the Expenses (in $) of Netherlands in 2003 to that in 2005?
Your answer should be compact. 0.97. What is the ratio of the Expenses (in $) of Slovenia in 2003 to that in 2005?
Offer a very short reply. 0.87. What is the ratio of the Expenses (in $) in Bahamas in 2003 to that in 2006?
Keep it short and to the point. 0.84. What is the ratio of the Expenses (in $) of Brazil in 2003 to that in 2006?
Offer a very short reply. 0.66. What is the ratio of the Expenses (in $) in Netherlands in 2003 to that in 2006?
Keep it short and to the point. 0.9. What is the ratio of the Expenses (in $) in Slovenia in 2003 to that in 2006?
Offer a terse response. 0.83. What is the ratio of the Expenses (in $) of Bahamas in 2003 to that in 2007?
Your answer should be very brief. 0.79. What is the ratio of the Expenses (in $) of Brazil in 2003 to that in 2007?
Give a very brief answer. 0.59. What is the ratio of the Expenses (in $) of Netherlands in 2003 to that in 2007?
Make the answer very short. 0.86. What is the ratio of the Expenses (in $) of Slovenia in 2003 to that in 2007?
Offer a terse response. 0.8. What is the ratio of the Expenses (in $) in Bahamas in 2004 to that in 2005?
Your response must be concise. 0.91. What is the ratio of the Expenses (in $) in Brazil in 2004 to that in 2005?
Your answer should be compact. 0.81. What is the ratio of the Expenses (in $) of Netherlands in 2004 to that in 2005?
Your response must be concise. 0.98. What is the ratio of the Expenses (in $) in Slovenia in 2004 to that in 2005?
Offer a terse response. 0.93. What is the ratio of the Expenses (in $) of Bahamas in 2004 to that in 2006?
Give a very brief answer. 0.86. What is the ratio of the Expenses (in $) of Brazil in 2004 to that in 2006?
Keep it short and to the point. 0.69. What is the ratio of the Expenses (in $) of Netherlands in 2004 to that in 2006?
Provide a short and direct response. 0.91. What is the ratio of the Expenses (in $) of Slovenia in 2004 to that in 2006?
Give a very brief answer. 0.89. What is the ratio of the Expenses (in $) of Bahamas in 2004 to that in 2007?
Make the answer very short. 0.81. What is the ratio of the Expenses (in $) of Brazil in 2004 to that in 2007?
Make the answer very short. 0.62. What is the ratio of the Expenses (in $) of Netherlands in 2004 to that in 2007?
Your answer should be compact. 0.87. What is the ratio of the Expenses (in $) of Slovenia in 2004 to that in 2007?
Ensure brevity in your answer.  0.86. What is the ratio of the Expenses (in $) in Bahamas in 2005 to that in 2006?
Offer a very short reply. 0.94. What is the ratio of the Expenses (in $) in Brazil in 2005 to that in 2006?
Ensure brevity in your answer.  0.85. What is the ratio of the Expenses (in $) in Netherlands in 2005 to that in 2006?
Your response must be concise. 0.92. What is the ratio of the Expenses (in $) of Slovenia in 2005 to that in 2006?
Ensure brevity in your answer.  0.95. What is the ratio of the Expenses (in $) of Bahamas in 2005 to that in 2007?
Make the answer very short. 0.89. What is the ratio of the Expenses (in $) in Brazil in 2005 to that in 2007?
Your answer should be very brief. 0.77. What is the ratio of the Expenses (in $) in Netherlands in 2005 to that in 2007?
Provide a short and direct response. 0.88. What is the ratio of the Expenses (in $) in Slovenia in 2005 to that in 2007?
Ensure brevity in your answer.  0.92. What is the ratio of the Expenses (in $) of Bahamas in 2006 to that in 2007?
Your answer should be compact. 0.94. What is the ratio of the Expenses (in $) in Brazil in 2006 to that in 2007?
Make the answer very short. 0.9. What is the ratio of the Expenses (in $) of Netherlands in 2006 to that in 2007?
Your response must be concise. 0.95. What is the ratio of the Expenses (in $) of Slovenia in 2006 to that in 2007?
Ensure brevity in your answer.  0.97. What is the difference between the highest and the second highest Expenses (in $) of Bahamas?
Keep it short and to the point. 7.43e+07. What is the difference between the highest and the second highest Expenses (in $) of Brazil?
Your answer should be very brief. 6.83e+1. What is the difference between the highest and the second highest Expenses (in $) of Netherlands?
Your response must be concise. 1.04e+1. What is the difference between the highest and the second highest Expenses (in $) of Slovenia?
Make the answer very short. 3.44e+08. What is the difference between the highest and the lowest Expenses (in $) in Bahamas?
Give a very brief answer. 3.93e+08. What is the difference between the highest and the lowest Expenses (in $) in Brazil?
Provide a short and direct response. 4.16e+11. What is the difference between the highest and the lowest Expenses (in $) in Netherlands?
Make the answer very short. 5.12e+1. What is the difference between the highest and the lowest Expenses (in $) of Slovenia?
Your answer should be very brief. 4.08e+09. 